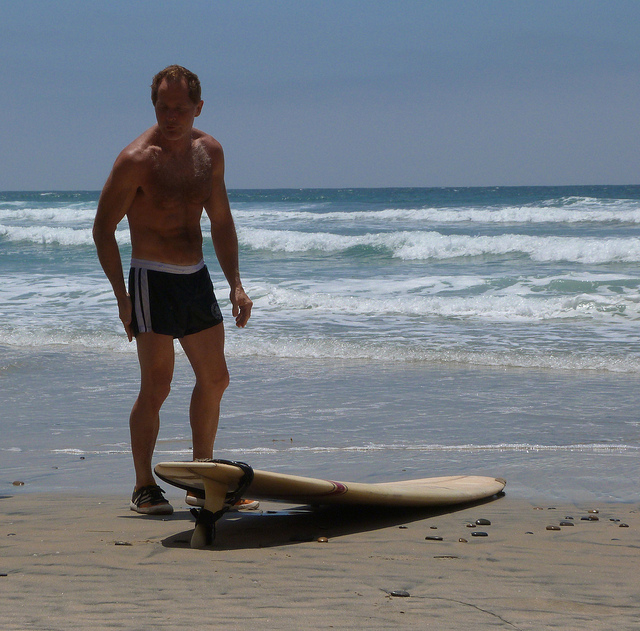Describe the condition of the beach. The beach appears to have a mix of sand and small pebbles scattered around. The sand looks firm and slightly wet, suggesting proximity to the waterline. The overall condition seems clean with no visible litter, providing a natural and serene environment. Are there any indications of wildlife or sea creatures in the image? No, the image does not show any indications of wildlife or sea creatures. The main focus is on the man and the surfboard, with the sea in the background. 